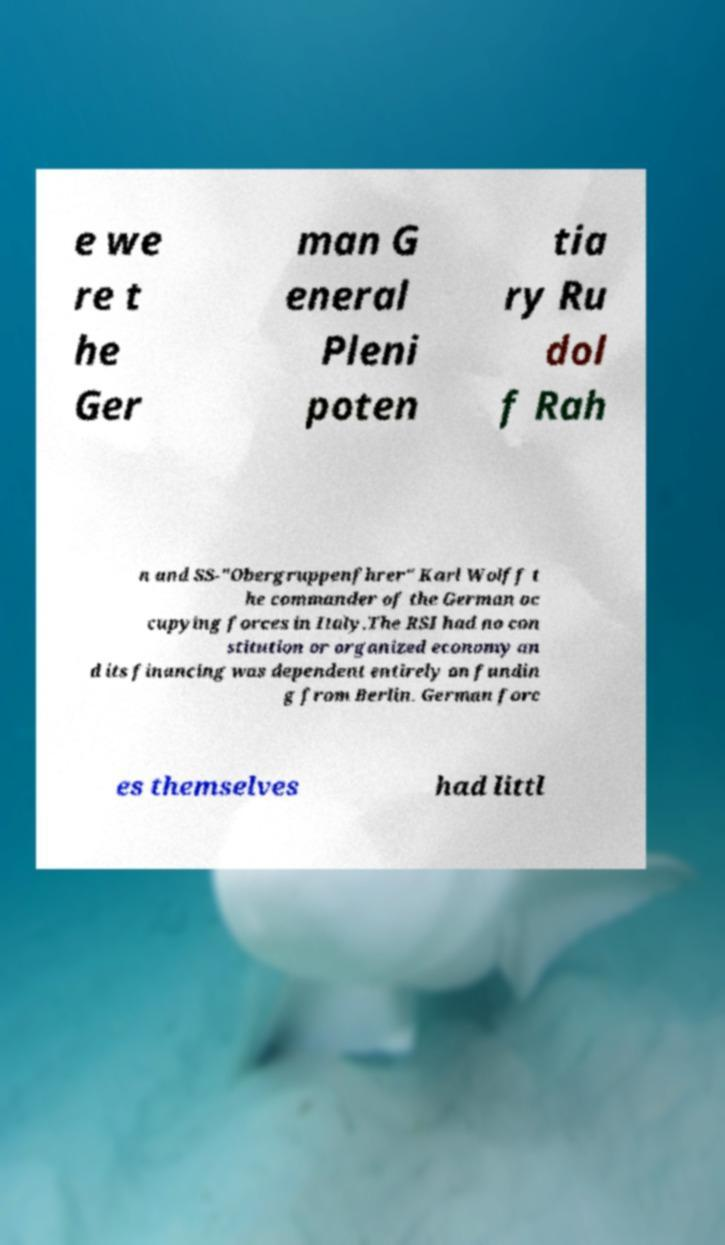Can you read and provide the text displayed in the image?This photo seems to have some interesting text. Can you extract and type it out for me? e we re t he Ger man G eneral Pleni poten tia ry Ru dol f Rah n and SS-"Obergruppenfhrer" Karl Wolff t he commander of the German oc cupying forces in Italy.The RSI had no con stitution or organized economy an d its financing was dependent entirely on fundin g from Berlin. German forc es themselves had littl 